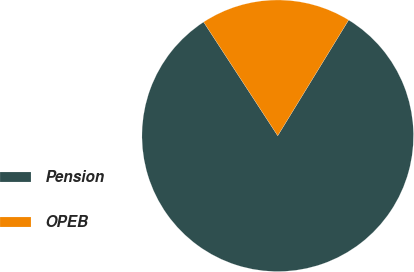<chart> <loc_0><loc_0><loc_500><loc_500><pie_chart><fcel>Pension<fcel>OPEB<nl><fcel>82.06%<fcel>17.94%<nl></chart> 